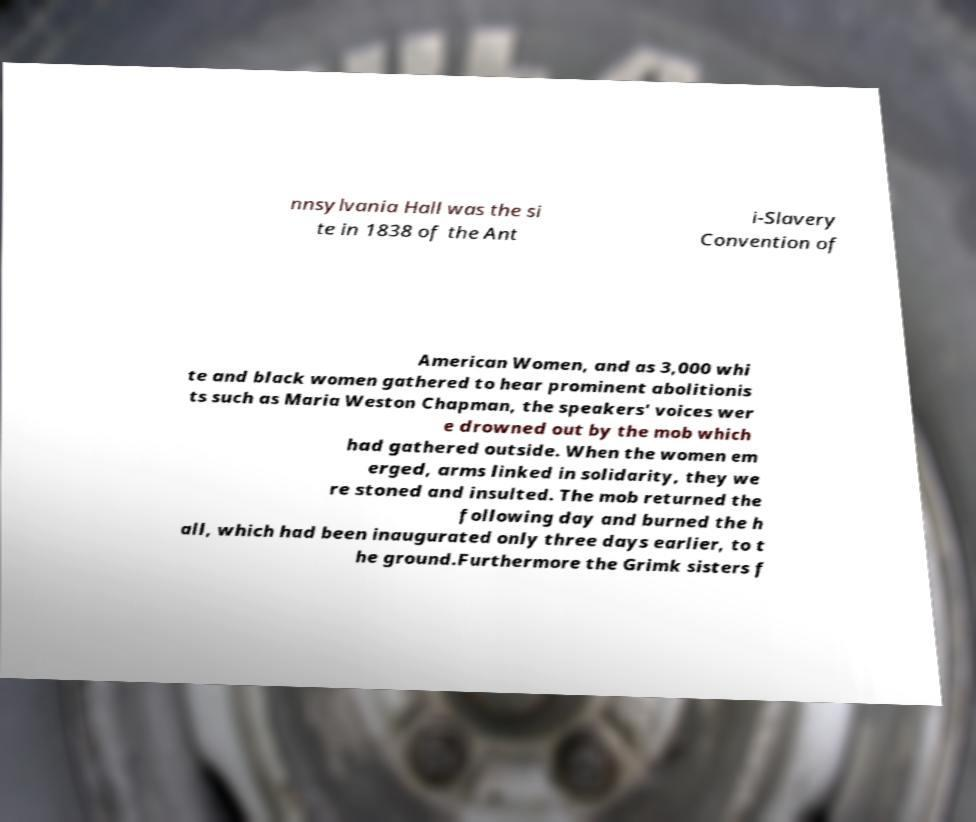There's text embedded in this image that I need extracted. Can you transcribe it verbatim? nnsylvania Hall was the si te in 1838 of the Ant i-Slavery Convention of American Women, and as 3,000 whi te and black women gathered to hear prominent abolitionis ts such as Maria Weston Chapman, the speakers' voices wer e drowned out by the mob which had gathered outside. When the women em erged, arms linked in solidarity, they we re stoned and insulted. The mob returned the following day and burned the h all, which had been inaugurated only three days earlier, to t he ground.Furthermore the Grimk sisters f 